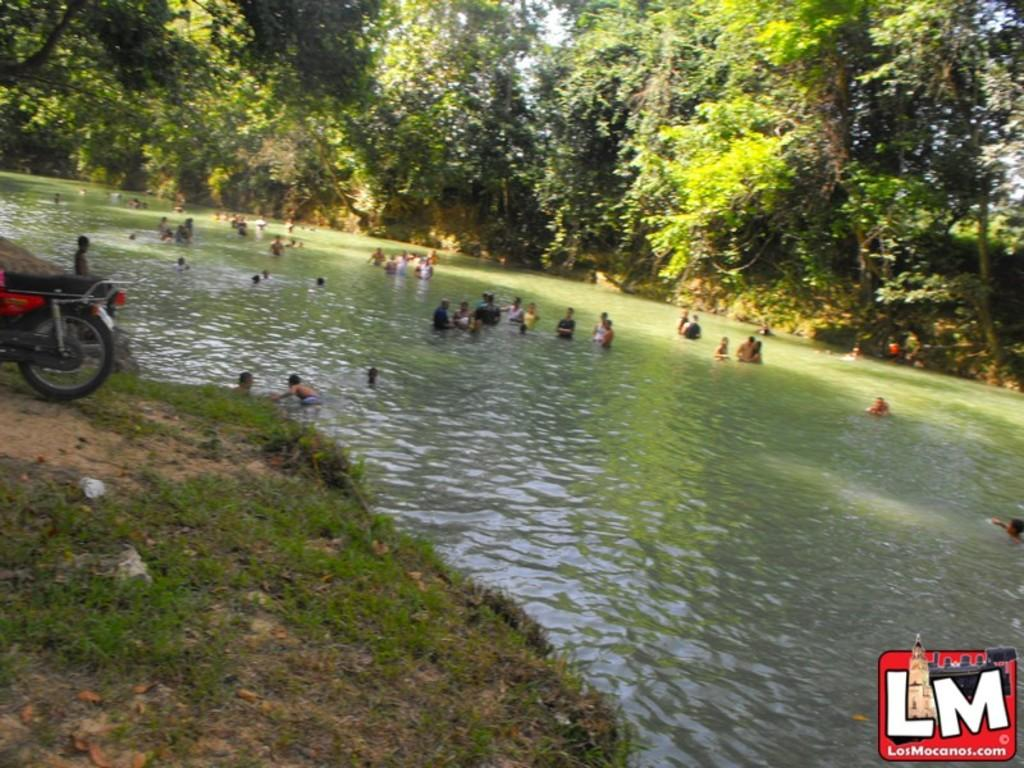What are the people in the image doing? The people in the image are in the water. What can be seen in the background of the image? There are trees and a bike visible in the background. What type of surface is visible in the image? There is ground visible in the image. Can you describe any additional details about the image? There is a logo present in the image. What type of ornament is hanging from the tree in the image? There is no ornament hanging from the tree in the image; only trees and a bike are visible in the background. What season is depicted in the image? The provided facts do not indicate a specific season, so it cannot be determined from the image. 